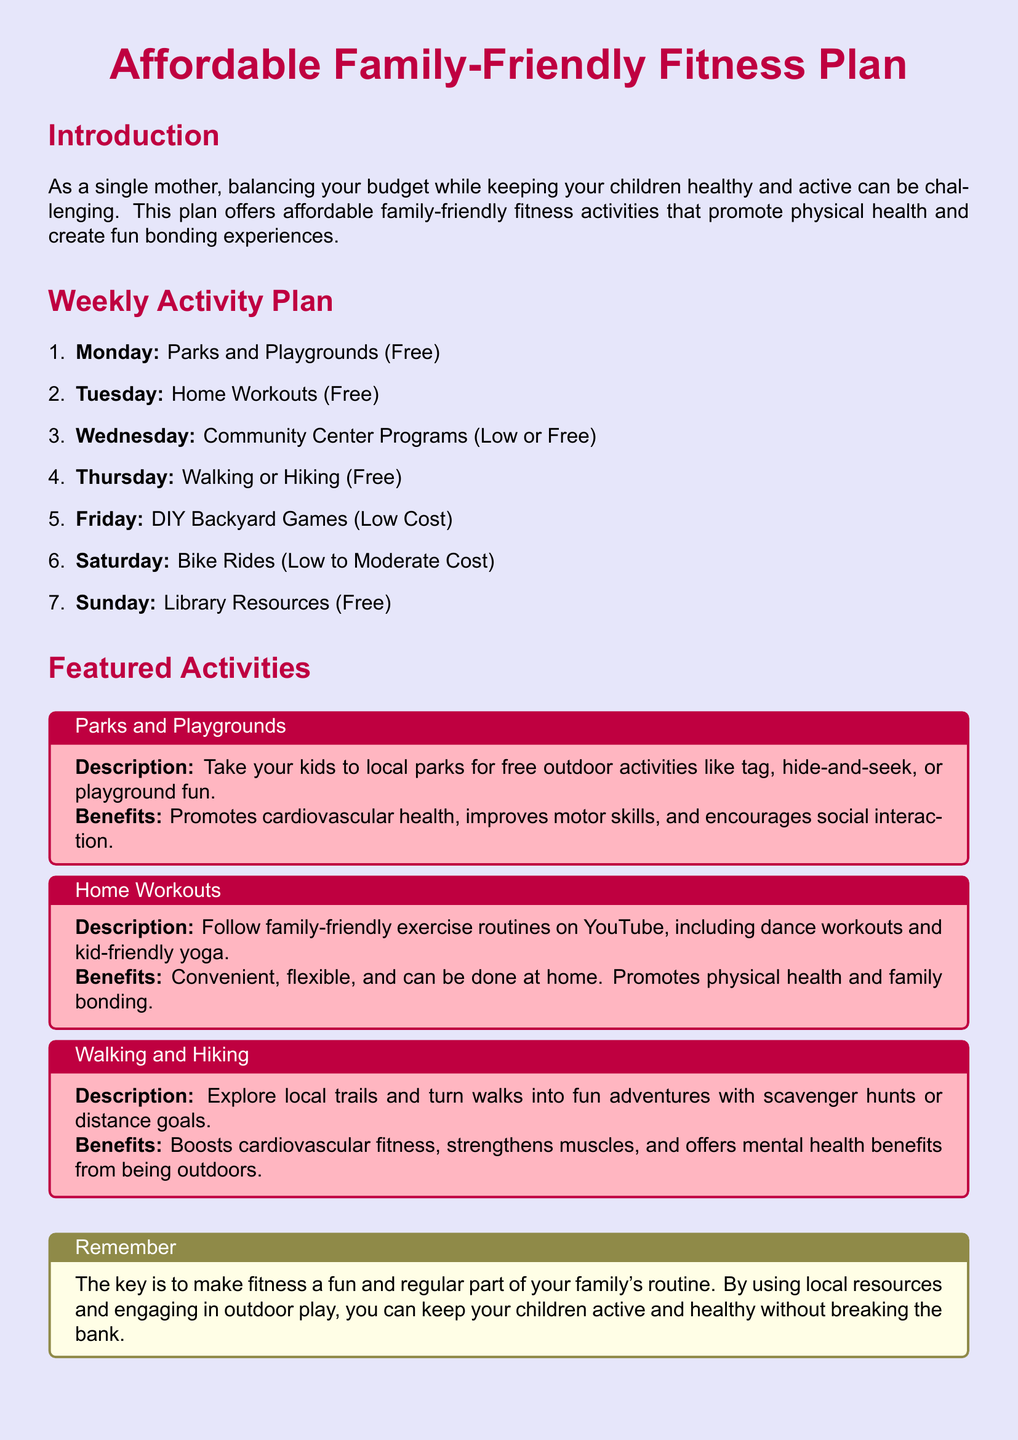What is the title of the document? The title of the document emphasizes the focus on affordable fitness for families, which is "Affordable Family-Friendly Fitness Plan."
Answer: Affordable Family-Friendly Fitness Plan How many activities are listed in the weekly plan? The activities are enumerated in the weekly activity plan section, totaling seven activities from Monday to Sunday.
Answer: 7 What activity is suggested for Wednesdays? The weekly plan specifies that Wednesdays are for participating in community center programs, which may be low-cost or free.
Answer: Community Center Programs What is one benefit of home workouts? The document states that home workouts are convenient and flexible, allowing families to exercise together.
Answer: Convenient, flexible Which day is dedicated to DIY backyard games? The weekly plan indicates that Friday is the designated day for DIY backyard games.
Answer: Friday What color is used for the background of the document? The background color of the document is lavender, as described in the design specifications.
Answer: Lavender What activity is recommended for Saturdays? Saturdays are suggested for bike rides, which can incur low to moderate costs according to the weekly plan.
Answer: Bike Rides What key message is highlighted in the "Remember" box? The key message emphasizes making fitness a fun and regular part of the family's routine, utilizing local resources for activities.
Answer: Make fitness fun and regular 